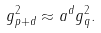<formula> <loc_0><loc_0><loc_500><loc_500>g ^ { 2 } _ { p + d } \approx a ^ { d } g ^ { 2 } _ { q } .</formula> 